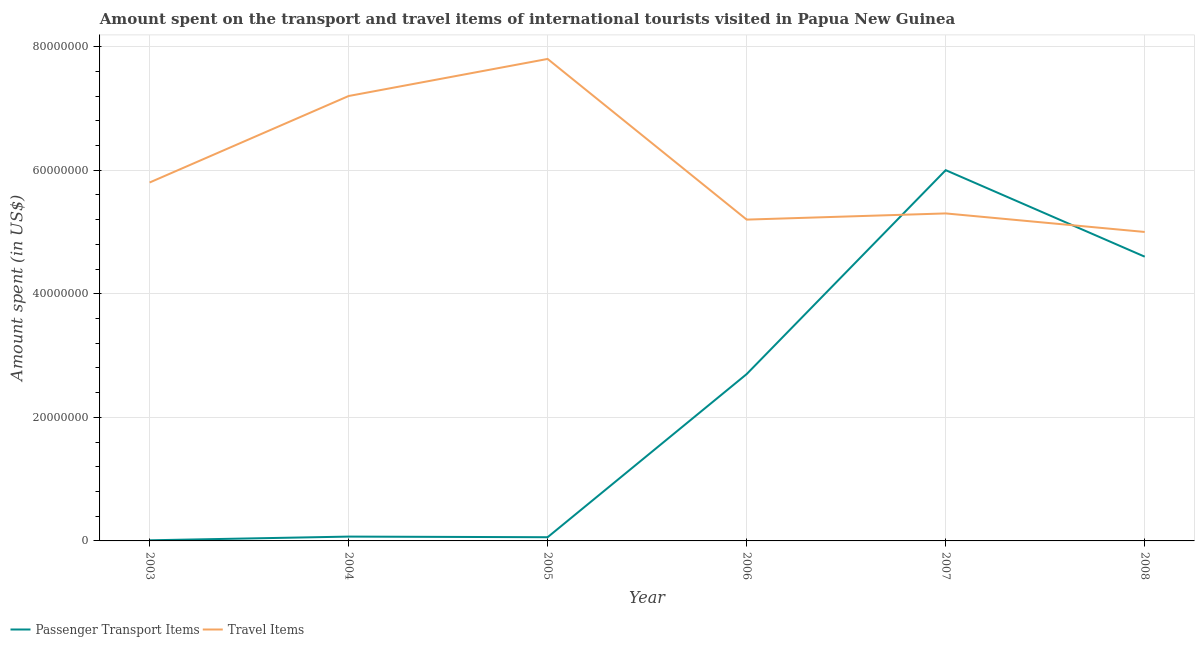How many different coloured lines are there?
Make the answer very short. 2. Does the line corresponding to amount spent in travel items intersect with the line corresponding to amount spent on passenger transport items?
Give a very brief answer. Yes. Is the number of lines equal to the number of legend labels?
Give a very brief answer. Yes. What is the amount spent in travel items in 2004?
Your response must be concise. 7.20e+07. Across all years, what is the maximum amount spent in travel items?
Provide a short and direct response. 7.80e+07. Across all years, what is the minimum amount spent on passenger transport items?
Your answer should be very brief. 1.00e+05. What is the total amount spent on passenger transport items in the graph?
Keep it short and to the point. 1.34e+08. What is the difference between the amount spent on passenger transport items in 2003 and that in 2008?
Your answer should be very brief. -4.59e+07. What is the difference between the amount spent on passenger transport items in 2006 and the amount spent in travel items in 2008?
Keep it short and to the point. -2.30e+07. What is the average amount spent on passenger transport items per year?
Offer a very short reply. 2.24e+07. In the year 2006, what is the difference between the amount spent on passenger transport items and amount spent in travel items?
Give a very brief answer. -2.50e+07. What is the ratio of the amount spent in travel items in 2004 to that in 2007?
Offer a very short reply. 1.36. Is the amount spent on passenger transport items in 2004 less than that in 2005?
Your answer should be very brief. No. What is the difference between the highest and the lowest amount spent on passenger transport items?
Your response must be concise. 5.99e+07. In how many years, is the amount spent in travel items greater than the average amount spent in travel items taken over all years?
Offer a terse response. 2. Is the sum of the amount spent in travel items in 2006 and 2007 greater than the maximum amount spent on passenger transport items across all years?
Make the answer very short. Yes. Does the amount spent in travel items monotonically increase over the years?
Offer a terse response. No. Is the amount spent in travel items strictly greater than the amount spent on passenger transport items over the years?
Give a very brief answer. No. How many lines are there?
Offer a terse response. 2. How many years are there in the graph?
Your answer should be compact. 6. What is the difference between two consecutive major ticks on the Y-axis?
Ensure brevity in your answer.  2.00e+07. Are the values on the major ticks of Y-axis written in scientific E-notation?
Offer a very short reply. No. Does the graph contain grids?
Offer a very short reply. Yes. How many legend labels are there?
Your answer should be compact. 2. What is the title of the graph?
Offer a terse response. Amount spent on the transport and travel items of international tourists visited in Papua New Guinea. What is the label or title of the X-axis?
Provide a succinct answer. Year. What is the label or title of the Y-axis?
Offer a very short reply. Amount spent (in US$). What is the Amount spent (in US$) of Travel Items in 2003?
Provide a short and direct response. 5.80e+07. What is the Amount spent (in US$) of Travel Items in 2004?
Your answer should be very brief. 7.20e+07. What is the Amount spent (in US$) of Travel Items in 2005?
Give a very brief answer. 7.80e+07. What is the Amount spent (in US$) of Passenger Transport Items in 2006?
Provide a short and direct response. 2.70e+07. What is the Amount spent (in US$) in Travel Items in 2006?
Offer a very short reply. 5.20e+07. What is the Amount spent (in US$) of Passenger Transport Items in 2007?
Give a very brief answer. 6.00e+07. What is the Amount spent (in US$) in Travel Items in 2007?
Your answer should be very brief. 5.30e+07. What is the Amount spent (in US$) in Passenger Transport Items in 2008?
Keep it short and to the point. 4.60e+07. Across all years, what is the maximum Amount spent (in US$) in Passenger Transport Items?
Give a very brief answer. 6.00e+07. Across all years, what is the maximum Amount spent (in US$) in Travel Items?
Your answer should be very brief. 7.80e+07. Across all years, what is the minimum Amount spent (in US$) of Passenger Transport Items?
Your response must be concise. 1.00e+05. What is the total Amount spent (in US$) of Passenger Transport Items in the graph?
Provide a succinct answer. 1.34e+08. What is the total Amount spent (in US$) in Travel Items in the graph?
Offer a terse response. 3.63e+08. What is the difference between the Amount spent (in US$) in Passenger Transport Items in 2003 and that in 2004?
Provide a short and direct response. -6.00e+05. What is the difference between the Amount spent (in US$) of Travel Items in 2003 and that in 2004?
Offer a very short reply. -1.40e+07. What is the difference between the Amount spent (in US$) in Passenger Transport Items in 2003 and that in 2005?
Your answer should be compact. -5.00e+05. What is the difference between the Amount spent (in US$) in Travel Items in 2003 and that in 2005?
Keep it short and to the point. -2.00e+07. What is the difference between the Amount spent (in US$) of Passenger Transport Items in 2003 and that in 2006?
Provide a short and direct response. -2.69e+07. What is the difference between the Amount spent (in US$) of Passenger Transport Items in 2003 and that in 2007?
Your answer should be very brief. -5.99e+07. What is the difference between the Amount spent (in US$) in Passenger Transport Items in 2003 and that in 2008?
Ensure brevity in your answer.  -4.59e+07. What is the difference between the Amount spent (in US$) of Travel Items in 2003 and that in 2008?
Make the answer very short. 8.00e+06. What is the difference between the Amount spent (in US$) in Passenger Transport Items in 2004 and that in 2005?
Offer a terse response. 1.00e+05. What is the difference between the Amount spent (in US$) of Travel Items in 2004 and that in 2005?
Make the answer very short. -6.00e+06. What is the difference between the Amount spent (in US$) of Passenger Transport Items in 2004 and that in 2006?
Provide a short and direct response. -2.63e+07. What is the difference between the Amount spent (in US$) of Travel Items in 2004 and that in 2006?
Your response must be concise. 2.00e+07. What is the difference between the Amount spent (in US$) of Passenger Transport Items in 2004 and that in 2007?
Provide a short and direct response. -5.93e+07. What is the difference between the Amount spent (in US$) of Travel Items in 2004 and that in 2007?
Ensure brevity in your answer.  1.90e+07. What is the difference between the Amount spent (in US$) in Passenger Transport Items in 2004 and that in 2008?
Provide a short and direct response. -4.53e+07. What is the difference between the Amount spent (in US$) in Travel Items in 2004 and that in 2008?
Provide a short and direct response. 2.20e+07. What is the difference between the Amount spent (in US$) of Passenger Transport Items in 2005 and that in 2006?
Offer a very short reply. -2.64e+07. What is the difference between the Amount spent (in US$) of Travel Items in 2005 and that in 2006?
Make the answer very short. 2.60e+07. What is the difference between the Amount spent (in US$) in Passenger Transport Items in 2005 and that in 2007?
Your answer should be compact. -5.94e+07. What is the difference between the Amount spent (in US$) in Travel Items in 2005 and that in 2007?
Provide a succinct answer. 2.50e+07. What is the difference between the Amount spent (in US$) in Passenger Transport Items in 2005 and that in 2008?
Your answer should be compact. -4.54e+07. What is the difference between the Amount spent (in US$) in Travel Items in 2005 and that in 2008?
Make the answer very short. 2.80e+07. What is the difference between the Amount spent (in US$) of Passenger Transport Items in 2006 and that in 2007?
Your answer should be compact. -3.30e+07. What is the difference between the Amount spent (in US$) of Travel Items in 2006 and that in 2007?
Your response must be concise. -1.00e+06. What is the difference between the Amount spent (in US$) in Passenger Transport Items in 2006 and that in 2008?
Provide a short and direct response. -1.90e+07. What is the difference between the Amount spent (in US$) in Travel Items in 2006 and that in 2008?
Make the answer very short. 2.00e+06. What is the difference between the Amount spent (in US$) in Passenger Transport Items in 2007 and that in 2008?
Give a very brief answer. 1.40e+07. What is the difference between the Amount spent (in US$) of Passenger Transport Items in 2003 and the Amount spent (in US$) of Travel Items in 2004?
Your answer should be very brief. -7.19e+07. What is the difference between the Amount spent (in US$) in Passenger Transport Items in 2003 and the Amount spent (in US$) in Travel Items in 2005?
Provide a succinct answer. -7.79e+07. What is the difference between the Amount spent (in US$) of Passenger Transport Items in 2003 and the Amount spent (in US$) of Travel Items in 2006?
Your response must be concise. -5.19e+07. What is the difference between the Amount spent (in US$) of Passenger Transport Items in 2003 and the Amount spent (in US$) of Travel Items in 2007?
Your response must be concise. -5.29e+07. What is the difference between the Amount spent (in US$) in Passenger Transport Items in 2003 and the Amount spent (in US$) in Travel Items in 2008?
Keep it short and to the point. -4.99e+07. What is the difference between the Amount spent (in US$) of Passenger Transport Items in 2004 and the Amount spent (in US$) of Travel Items in 2005?
Provide a succinct answer. -7.73e+07. What is the difference between the Amount spent (in US$) in Passenger Transport Items in 2004 and the Amount spent (in US$) in Travel Items in 2006?
Offer a very short reply. -5.13e+07. What is the difference between the Amount spent (in US$) in Passenger Transport Items in 2004 and the Amount spent (in US$) in Travel Items in 2007?
Offer a terse response. -5.23e+07. What is the difference between the Amount spent (in US$) of Passenger Transport Items in 2004 and the Amount spent (in US$) of Travel Items in 2008?
Provide a short and direct response. -4.93e+07. What is the difference between the Amount spent (in US$) of Passenger Transport Items in 2005 and the Amount spent (in US$) of Travel Items in 2006?
Your answer should be compact. -5.14e+07. What is the difference between the Amount spent (in US$) of Passenger Transport Items in 2005 and the Amount spent (in US$) of Travel Items in 2007?
Offer a terse response. -5.24e+07. What is the difference between the Amount spent (in US$) in Passenger Transport Items in 2005 and the Amount spent (in US$) in Travel Items in 2008?
Offer a very short reply. -4.94e+07. What is the difference between the Amount spent (in US$) of Passenger Transport Items in 2006 and the Amount spent (in US$) of Travel Items in 2007?
Keep it short and to the point. -2.60e+07. What is the difference between the Amount spent (in US$) in Passenger Transport Items in 2006 and the Amount spent (in US$) in Travel Items in 2008?
Provide a succinct answer. -2.30e+07. What is the difference between the Amount spent (in US$) in Passenger Transport Items in 2007 and the Amount spent (in US$) in Travel Items in 2008?
Provide a short and direct response. 1.00e+07. What is the average Amount spent (in US$) of Passenger Transport Items per year?
Offer a very short reply. 2.24e+07. What is the average Amount spent (in US$) in Travel Items per year?
Provide a short and direct response. 6.05e+07. In the year 2003, what is the difference between the Amount spent (in US$) in Passenger Transport Items and Amount spent (in US$) in Travel Items?
Provide a succinct answer. -5.79e+07. In the year 2004, what is the difference between the Amount spent (in US$) in Passenger Transport Items and Amount spent (in US$) in Travel Items?
Give a very brief answer. -7.13e+07. In the year 2005, what is the difference between the Amount spent (in US$) in Passenger Transport Items and Amount spent (in US$) in Travel Items?
Provide a succinct answer. -7.74e+07. In the year 2006, what is the difference between the Amount spent (in US$) of Passenger Transport Items and Amount spent (in US$) of Travel Items?
Offer a very short reply. -2.50e+07. In the year 2007, what is the difference between the Amount spent (in US$) in Passenger Transport Items and Amount spent (in US$) in Travel Items?
Offer a terse response. 7.00e+06. In the year 2008, what is the difference between the Amount spent (in US$) of Passenger Transport Items and Amount spent (in US$) of Travel Items?
Offer a terse response. -4.00e+06. What is the ratio of the Amount spent (in US$) in Passenger Transport Items in 2003 to that in 2004?
Keep it short and to the point. 0.14. What is the ratio of the Amount spent (in US$) of Travel Items in 2003 to that in 2004?
Make the answer very short. 0.81. What is the ratio of the Amount spent (in US$) of Passenger Transport Items in 2003 to that in 2005?
Make the answer very short. 0.17. What is the ratio of the Amount spent (in US$) in Travel Items in 2003 to that in 2005?
Make the answer very short. 0.74. What is the ratio of the Amount spent (in US$) in Passenger Transport Items in 2003 to that in 2006?
Offer a terse response. 0. What is the ratio of the Amount spent (in US$) in Travel Items in 2003 to that in 2006?
Your answer should be compact. 1.12. What is the ratio of the Amount spent (in US$) of Passenger Transport Items in 2003 to that in 2007?
Offer a terse response. 0. What is the ratio of the Amount spent (in US$) in Travel Items in 2003 to that in 2007?
Offer a very short reply. 1.09. What is the ratio of the Amount spent (in US$) of Passenger Transport Items in 2003 to that in 2008?
Offer a very short reply. 0. What is the ratio of the Amount spent (in US$) of Travel Items in 2003 to that in 2008?
Your response must be concise. 1.16. What is the ratio of the Amount spent (in US$) in Travel Items in 2004 to that in 2005?
Keep it short and to the point. 0.92. What is the ratio of the Amount spent (in US$) in Passenger Transport Items in 2004 to that in 2006?
Offer a very short reply. 0.03. What is the ratio of the Amount spent (in US$) in Travel Items in 2004 to that in 2006?
Your answer should be compact. 1.38. What is the ratio of the Amount spent (in US$) of Passenger Transport Items in 2004 to that in 2007?
Provide a short and direct response. 0.01. What is the ratio of the Amount spent (in US$) of Travel Items in 2004 to that in 2007?
Give a very brief answer. 1.36. What is the ratio of the Amount spent (in US$) of Passenger Transport Items in 2004 to that in 2008?
Provide a short and direct response. 0.02. What is the ratio of the Amount spent (in US$) of Travel Items in 2004 to that in 2008?
Your answer should be very brief. 1.44. What is the ratio of the Amount spent (in US$) of Passenger Transport Items in 2005 to that in 2006?
Give a very brief answer. 0.02. What is the ratio of the Amount spent (in US$) of Travel Items in 2005 to that in 2006?
Your answer should be compact. 1.5. What is the ratio of the Amount spent (in US$) of Travel Items in 2005 to that in 2007?
Keep it short and to the point. 1.47. What is the ratio of the Amount spent (in US$) of Passenger Transport Items in 2005 to that in 2008?
Your answer should be very brief. 0.01. What is the ratio of the Amount spent (in US$) of Travel Items in 2005 to that in 2008?
Give a very brief answer. 1.56. What is the ratio of the Amount spent (in US$) of Passenger Transport Items in 2006 to that in 2007?
Provide a succinct answer. 0.45. What is the ratio of the Amount spent (in US$) of Travel Items in 2006 to that in 2007?
Provide a succinct answer. 0.98. What is the ratio of the Amount spent (in US$) of Passenger Transport Items in 2006 to that in 2008?
Offer a terse response. 0.59. What is the ratio of the Amount spent (in US$) in Passenger Transport Items in 2007 to that in 2008?
Offer a terse response. 1.3. What is the ratio of the Amount spent (in US$) of Travel Items in 2007 to that in 2008?
Provide a succinct answer. 1.06. What is the difference between the highest and the second highest Amount spent (in US$) of Passenger Transport Items?
Your answer should be compact. 1.40e+07. What is the difference between the highest and the second highest Amount spent (in US$) in Travel Items?
Your response must be concise. 6.00e+06. What is the difference between the highest and the lowest Amount spent (in US$) of Passenger Transport Items?
Offer a very short reply. 5.99e+07. What is the difference between the highest and the lowest Amount spent (in US$) in Travel Items?
Your answer should be very brief. 2.80e+07. 